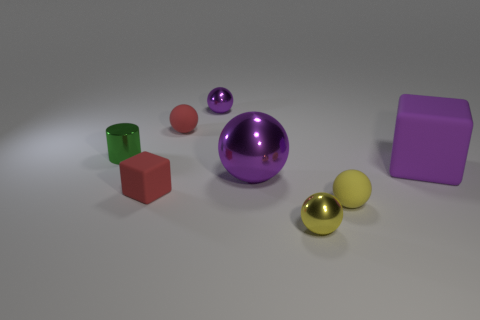What could be the size comparison between the green and red object? The green and red objects both appear to be cubes and are roughly the same size in comparison to each other; however, due to perspective, the green cube might seem marginally smaller. 